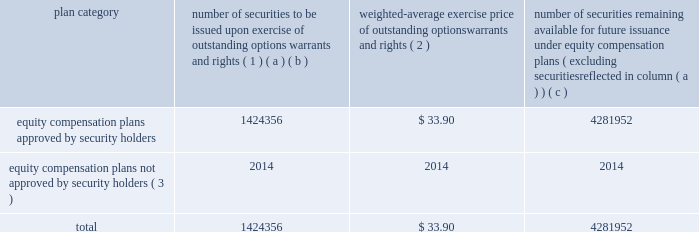Equity compensation plan information the table presents the equity securities available for issuance under our equity compensation plans as of december 31 , 2015 .
Equity compensation plan information plan category number of securities to be issued upon exercise of outstanding options , warrants and rights ( 1 ) weighted-average exercise price of outstanding options , warrants and rights ( 2 ) number of securities remaining available for future issuance under equity compensation plans ( excluding securities reflected in column ( a ) ) ( a ) ( b ) ( c ) equity compensation plans approved by security holders 1424356 $ 33.90 4281952 equity compensation plans not approved by security holders ( 3 ) 2014 2014 2014 .
( 1 ) includes grants made under the huntington ingalls industries , inc .
2012 long-term incentive stock plan ( the "2012 plan" ) , which was approved by our stockholders on may 2 , 2012 , and the huntington ingalls industries , inc .
2011 long-term incentive stock plan ( the "2011 plan" ) , which was approved by the sole stockholder of hii prior to its spin-off from northrop grumman corporation .
Of these shares , 533397 were subject to stock options and 54191 were stock rights granted under the 2011 plan .
In addition , this number includes 35553 stock rights , 10279 restricted stock rights , and 790936 restricted performance stock rights granted under the 2012 plan , assuming target performance achievement .
( 2 ) this is the weighted average exercise price of the 533397 outstanding stock options only .
( 3 ) there are no awards made under plans not approved by security holders .
Item 13 .
Certain relationships and related transactions , and director independence information as to certain relationships and related transactions and director independence will be incorporated herein by reference to the proxy statement for our 2016 annual meeting of stockholders , to be filed within 120 days after the end of the company 2019s fiscal year .
Item 14 .
Principal accountant fees and services information as to principal accountant fees and services will be incorporated herein by reference to the proxy statement for our 2016 annual meeting of stockholders , to be filed within 120 days after the end of the company 2019s fiscal year. .
In the "2011 plan" what was the ratio of the stock option stock option stock to the stock rights? 
Rationale: in the "2011 plan" the ratio of stock options to stock rights was 9.8 to 1
Computations: (533397 / 54191)
Answer: 9.84291. Equity compensation plan information the table presents the equity securities available for issuance under our equity compensation plans as of december 31 , 2015 .
Equity compensation plan information plan category number of securities to be issued upon exercise of outstanding options , warrants and rights ( 1 ) weighted-average exercise price of outstanding options , warrants and rights ( 2 ) number of securities remaining available for future issuance under equity compensation plans ( excluding securities reflected in column ( a ) ) ( a ) ( b ) ( c ) equity compensation plans approved by security holders 1424356 $ 33.90 4281952 equity compensation plans not approved by security holders ( 3 ) 2014 2014 2014 .
( 1 ) includes grants made under the huntington ingalls industries , inc .
2012 long-term incentive stock plan ( the "2012 plan" ) , which was approved by our stockholders on may 2 , 2012 , and the huntington ingalls industries , inc .
2011 long-term incentive stock plan ( the "2011 plan" ) , which was approved by the sole stockholder of hii prior to its spin-off from northrop grumman corporation .
Of these shares , 533397 were subject to stock options and 54191 were stock rights granted under the 2011 plan .
In addition , this number includes 35553 stock rights , 10279 restricted stock rights , and 790936 restricted performance stock rights granted under the 2012 plan , assuming target performance achievement .
( 2 ) this is the weighted average exercise price of the 533397 outstanding stock options only .
( 3 ) there are no awards made under plans not approved by security holders .
Item 13 .
Certain relationships and related transactions , and director independence information as to certain relationships and related transactions and director independence will be incorporated herein by reference to the proxy statement for our 2016 annual meeting of stockholders , to be filed within 120 days after the end of the company 2019s fiscal year .
Item 14 .
Principal accountant fees and services information as to principal accountant fees and services will be incorporated herein by reference to the proxy statement for our 2016 annual meeting of stockholders , to be filed within 120 days after the end of the company 2019s fiscal year. .
What portion of the equity compensation plans approved by security holders remains available for future issuance? 
Computations: (4281952 / (1424356 + 4281952))
Answer: 0.75039. 